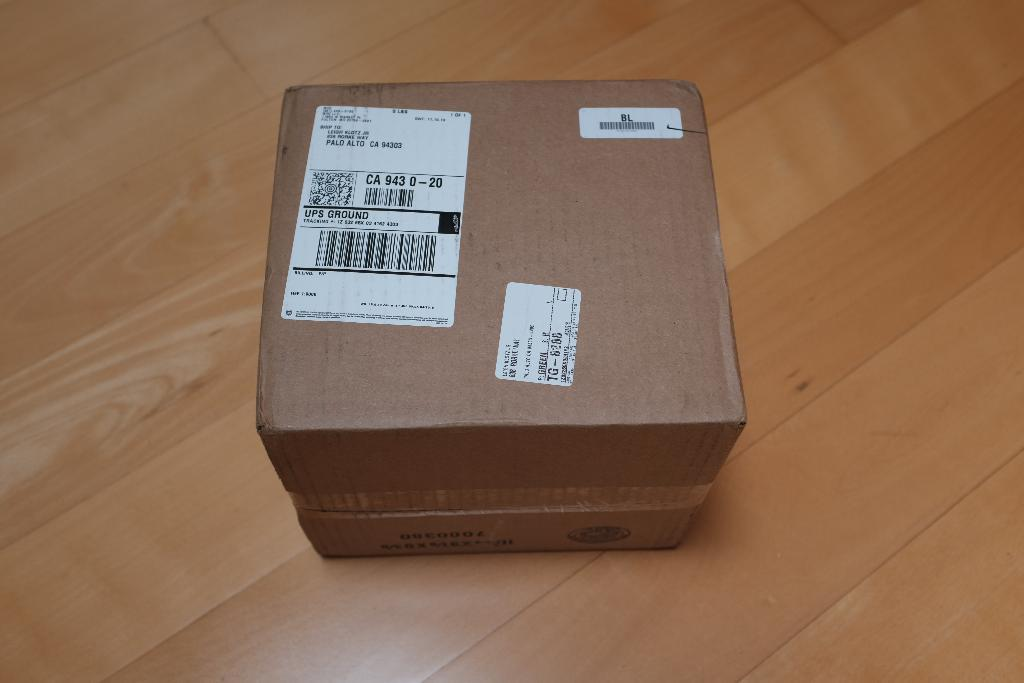What object is in the image that is made of cardboard? There is a cardboard box in the image. What can be found on the cardboard box? The cardboard box has labels on it. What type of surface is visible in the image? The wooden surface is present in the image. What type of silk material is draped over the cardboard box in the image? There is no silk material present in the image; it only features a cardboard box with labels and a wooden surface. 